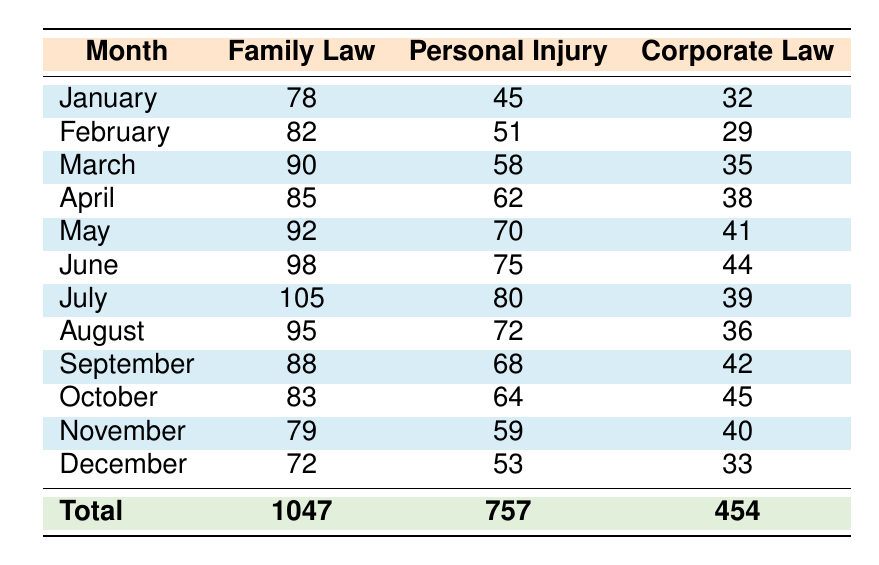What is the highest number of inquiries in a month for Family Law? The highest inquiry count for Family Law is seen in July with 105 inquiries.
Answer: 105 What is the total number of inquiries for Personal Injury throughout the year? Summing up the inquiry counts for Personal Injury from January to December gives 45 + 51 + 58 + 62 + 70 + 75 + 80 + 72 + 68 + 64 + 59 + 53 = 757.
Answer: 757 Was there an increase in Corporate Law inquiries from January to February? In January, there were 32 inquiries, and in February, there were 29 inquiries, which is a decrease.
Answer: No What is the average number of inquiries for Family Law over the entire year? The total inquiries for Family Law is 1047, and there are 12 months, so the average is 1047 / 12 = 87.25.
Answer: 87.25 In which month did Personal Injury inquiries reach their lowest point? The lowest count for Personal Injury occurs in January with 45 inquiries.
Answer: January What is the difference in inquiry counts for Family Law between the highest and lowest months? The highest is 105 inquiries in July, and the lowest is 72 inquiries in December, so the difference is 105 - 72 = 33.
Answer: 33 Did the inquiries for Corporate Law ever exceed 50 in any month? The highest inquiry count for Corporate Law is 45 in October, which does not exceed 50.
Answer: No Which legal practice area had the highest overall inquiries for the year? The total inquiries are 1047 for Family Law, 757 for Personal Injury, and 454 for Corporate Law. Family Law has the highest total.
Answer: Family Law What was the total inquiry count for all practice areas in August? For August, the counts are Family Law = 95, Personal Injury = 72, and Corporate Law = 36. The total is 95 + 72 + 36 = 203.
Answer: 203 How many more inquiries did Family Law receive compared to Corporate Law in June? In June, Family Law had 98 inquiries and Corporate Law had 44 inquiries. The difference is 98 - 44 = 54.
Answer: 54 